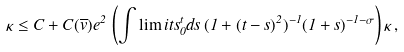Convert formula to latex. <formula><loc_0><loc_0><loc_500><loc_500>\kappa \leq C + C ( \overline { v } ) e ^ { 2 } \, \left ( \int \lim i t s _ { 0 } ^ { t } d s \, ( 1 + ( t - s ) ^ { 2 } ) ^ { - 1 } ( 1 + s ) ^ { - 1 - \sigma } \right ) \kappa \, ,</formula> 